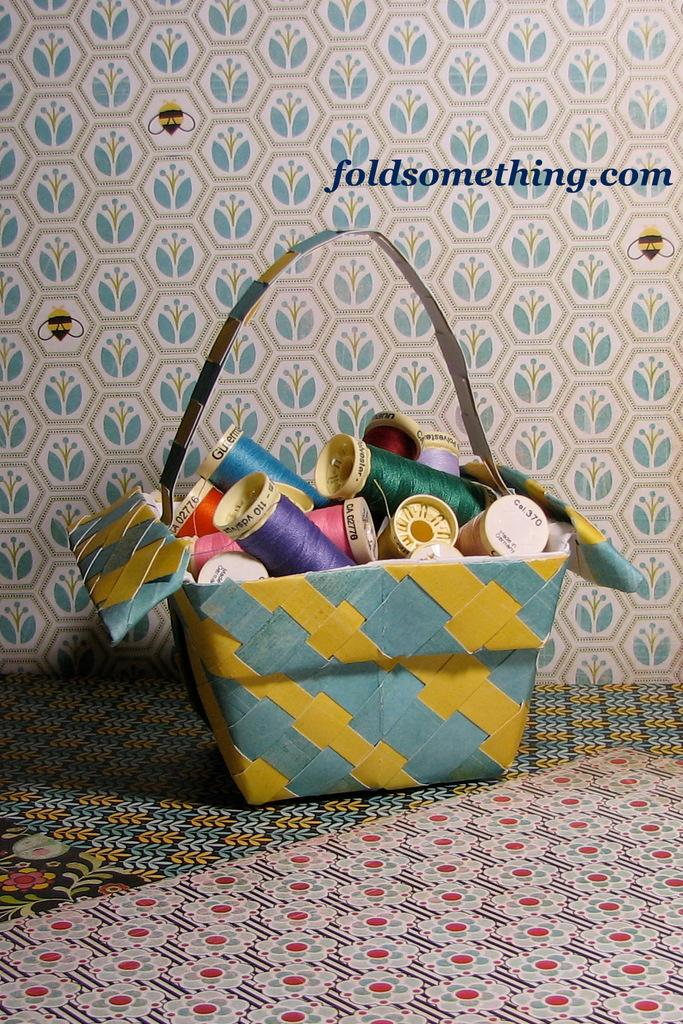What object is present in the image? There is a bag in the image. What is inside the bag? The bag contains a lot of threads. What can be seen in the background of the image? There is a well-designed wall in the background of the image. What time is the meeting scheduled for in the image? There is no mention of a meeting or time in the image. What type of lace can be seen on the threads in the image? There is no lace present in the image; it only contains threads. 